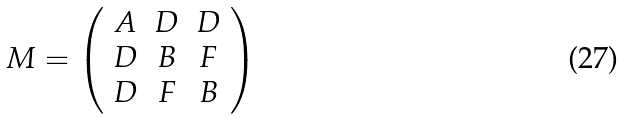<formula> <loc_0><loc_0><loc_500><loc_500>M = \left ( \begin{array} { c c c } A & D & D \\ D & B & F \\ D & F & B \end{array} \right )</formula> 